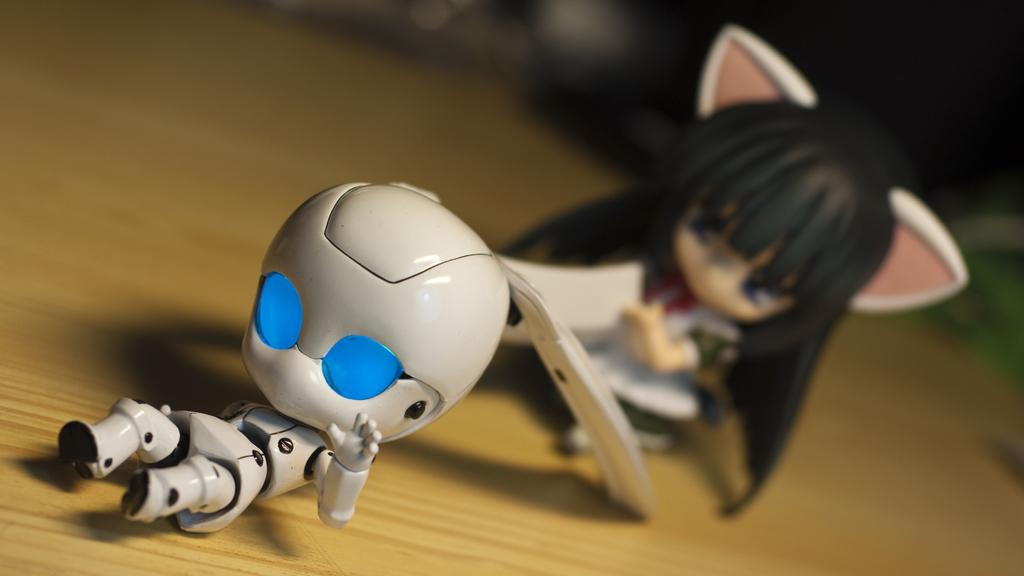What objects are present in the image? There are toys in the image. Where are the toys located? The toys are on a wooden table. How many mice can be seen operating the toys in the image? There are no mice present in the image, and the toys are not being operated by any animals. 